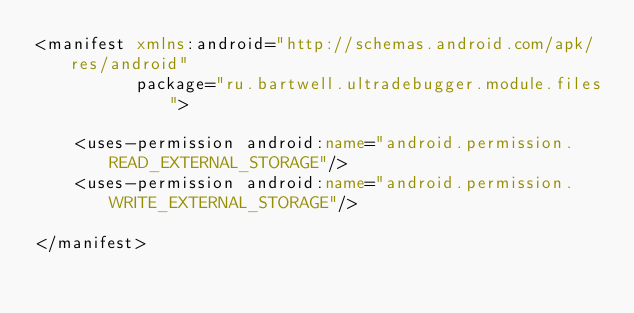Convert code to text. <code><loc_0><loc_0><loc_500><loc_500><_XML_><manifest xmlns:android="http://schemas.android.com/apk/res/android"
          package="ru.bartwell.ultradebugger.module.files">

    <uses-permission android:name="android.permission.READ_EXTERNAL_STORAGE"/>
    <uses-permission android:name="android.permission.WRITE_EXTERNAL_STORAGE"/>

</manifest>
</code> 